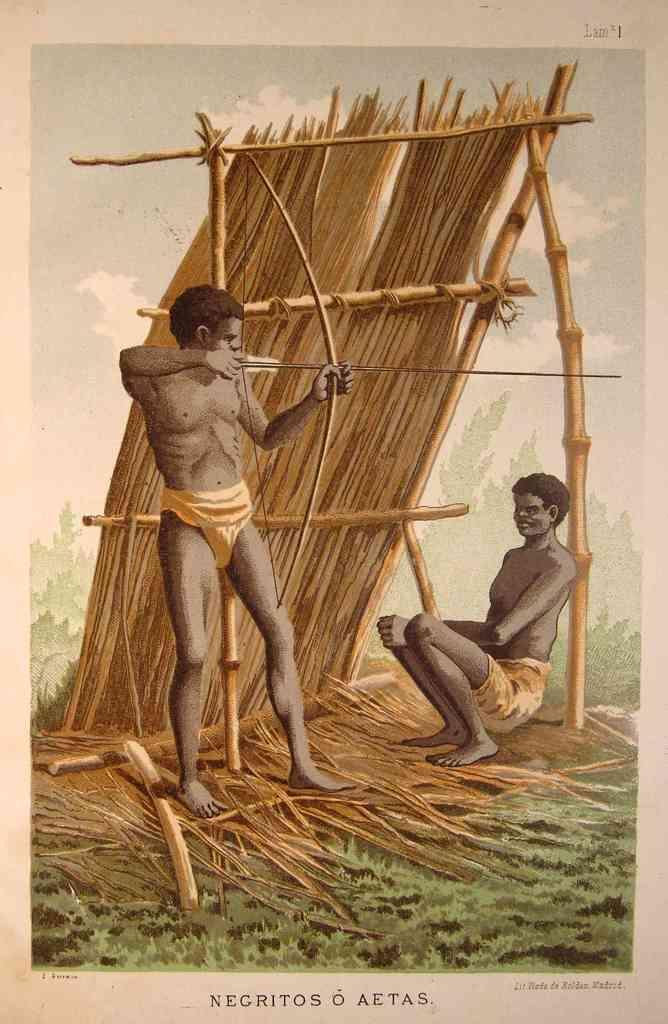Describe this image in one or two sentences. This image is a painting. In this image we can see persons, wooden sticks, grass, sky and clouds. 